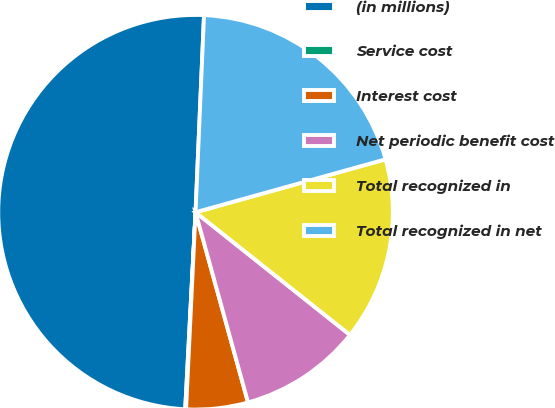Convert chart to OTSL. <chart><loc_0><loc_0><loc_500><loc_500><pie_chart><fcel>(in millions)<fcel>Service cost<fcel>Interest cost<fcel>Net periodic benefit cost<fcel>Total recognized in<fcel>Total recognized in net<nl><fcel>49.85%<fcel>0.07%<fcel>5.05%<fcel>10.03%<fcel>15.01%<fcel>19.99%<nl></chart> 